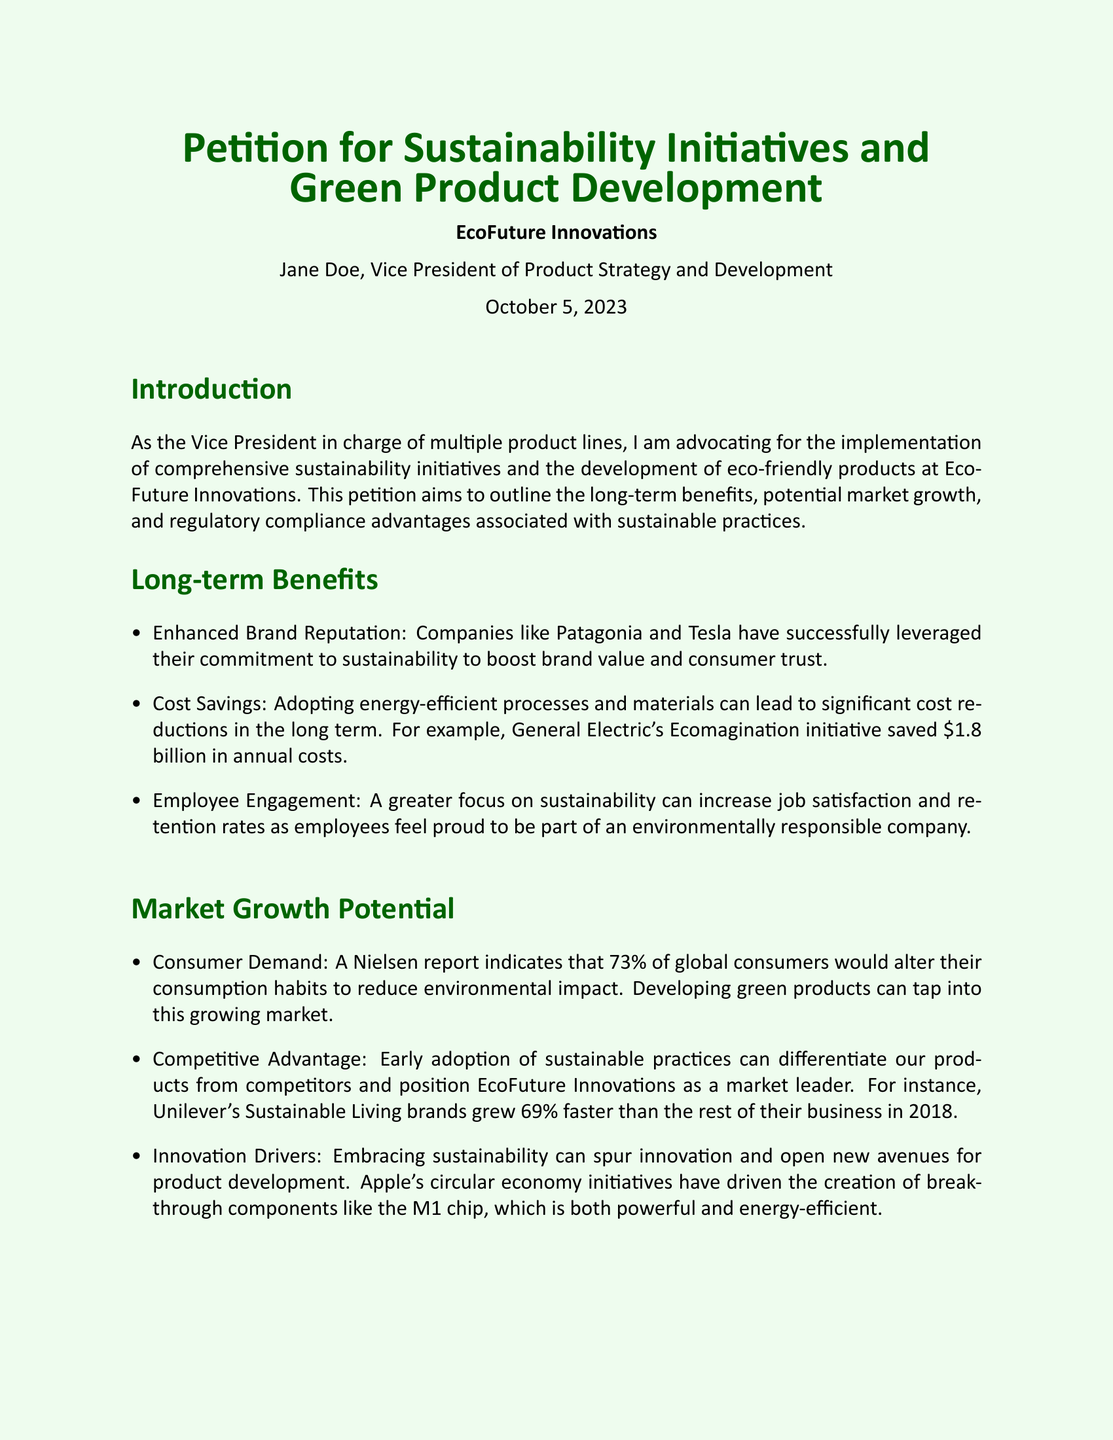What is the main goal of the petition? The petition aims to promote sustainable practices and the development of eco-friendly products.
Answer: Promote sustainable practices and eco-friendly products Who is the author of the petition? The petition is authored by Jane Doe, who is the Vice President of Product Strategy and Development.
Answer: Jane Doe When was the petition written? The petition was written on October 5, 2023.
Answer: October 5, 2023 What percentage of global consumers would change their habits to reduce environmental impact? A Nielsen report indicates that 73% of global consumers would change their consumption habits to reduce environmental impact.
Answer: 73% What initiative saved $1.8 billion in annual costs? General Electric's Ecomagination initiative saved $1.8 billion in annual costs.
Answer: Ecomagination Which company’s Sustainable Living brands grew 69% faster in 2018? Unilever's Sustainable Living brands grew 69% faster than the rest of their business in 2018.
Answer: Unilever What is one of the regulatory compliance advantages mentioned? Proactive compliance with regulations can prevent costly fines and legal issues.
Answer: Prevent costly fines What is the significance of the call to action? The call to action urges EcoFuture Innovations to implement sustainability initiatives and develop eco-friendly products.
Answer: Urges action for sustainability initiatives How many undersigned support the petition? Three individuals signed the petition including John Smith, Emily Johnson, and Michael Brown.
Answer: Three individuals 